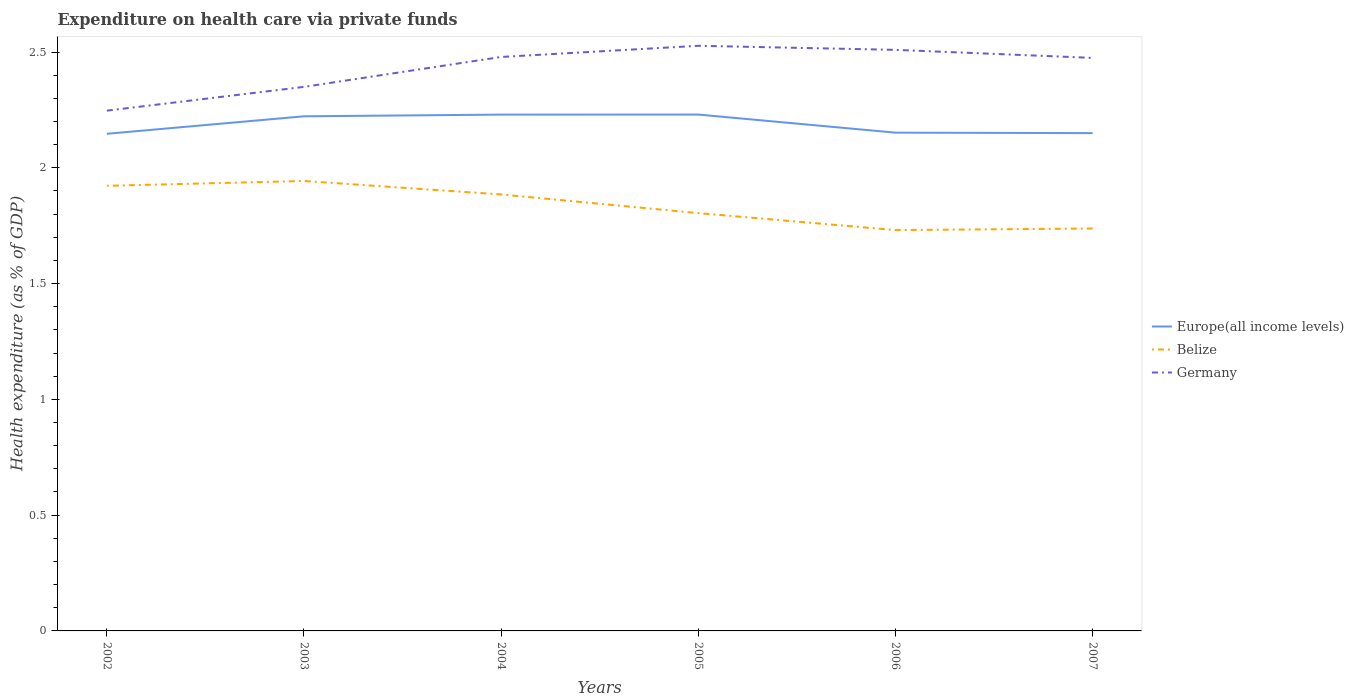How many different coloured lines are there?
Make the answer very short. 3. Across all years, what is the maximum expenditure made on health care in Germany?
Your response must be concise. 2.25. What is the total expenditure made on health care in Germany in the graph?
Offer a very short reply. 0.02. What is the difference between the highest and the second highest expenditure made on health care in Belize?
Provide a short and direct response. 0.21. What is the difference between the highest and the lowest expenditure made on health care in Europe(all income levels)?
Offer a very short reply. 3. How many lines are there?
Provide a short and direct response. 3. How many years are there in the graph?
Offer a terse response. 6. What is the difference between two consecutive major ticks on the Y-axis?
Provide a short and direct response. 0.5. Does the graph contain any zero values?
Make the answer very short. No. What is the title of the graph?
Ensure brevity in your answer.  Expenditure on health care via private funds. Does "Ukraine" appear as one of the legend labels in the graph?
Provide a short and direct response. No. What is the label or title of the X-axis?
Offer a terse response. Years. What is the label or title of the Y-axis?
Give a very brief answer. Health expenditure (as % of GDP). What is the Health expenditure (as % of GDP) of Europe(all income levels) in 2002?
Offer a very short reply. 2.15. What is the Health expenditure (as % of GDP) of Belize in 2002?
Your answer should be compact. 1.92. What is the Health expenditure (as % of GDP) of Germany in 2002?
Your answer should be compact. 2.25. What is the Health expenditure (as % of GDP) of Europe(all income levels) in 2003?
Offer a very short reply. 2.22. What is the Health expenditure (as % of GDP) of Belize in 2003?
Ensure brevity in your answer.  1.94. What is the Health expenditure (as % of GDP) of Germany in 2003?
Your answer should be very brief. 2.35. What is the Health expenditure (as % of GDP) in Europe(all income levels) in 2004?
Your answer should be compact. 2.23. What is the Health expenditure (as % of GDP) of Belize in 2004?
Your answer should be compact. 1.88. What is the Health expenditure (as % of GDP) of Germany in 2004?
Your answer should be compact. 2.48. What is the Health expenditure (as % of GDP) in Europe(all income levels) in 2005?
Provide a short and direct response. 2.23. What is the Health expenditure (as % of GDP) of Belize in 2005?
Your response must be concise. 1.8. What is the Health expenditure (as % of GDP) of Germany in 2005?
Keep it short and to the point. 2.53. What is the Health expenditure (as % of GDP) of Europe(all income levels) in 2006?
Your answer should be compact. 2.15. What is the Health expenditure (as % of GDP) in Belize in 2006?
Offer a terse response. 1.73. What is the Health expenditure (as % of GDP) of Germany in 2006?
Give a very brief answer. 2.51. What is the Health expenditure (as % of GDP) in Europe(all income levels) in 2007?
Your answer should be compact. 2.15. What is the Health expenditure (as % of GDP) in Belize in 2007?
Provide a succinct answer. 1.74. What is the Health expenditure (as % of GDP) in Germany in 2007?
Provide a succinct answer. 2.47. Across all years, what is the maximum Health expenditure (as % of GDP) of Europe(all income levels)?
Offer a very short reply. 2.23. Across all years, what is the maximum Health expenditure (as % of GDP) of Belize?
Your answer should be compact. 1.94. Across all years, what is the maximum Health expenditure (as % of GDP) of Germany?
Offer a terse response. 2.53. Across all years, what is the minimum Health expenditure (as % of GDP) of Europe(all income levels)?
Provide a short and direct response. 2.15. Across all years, what is the minimum Health expenditure (as % of GDP) of Belize?
Your answer should be very brief. 1.73. Across all years, what is the minimum Health expenditure (as % of GDP) in Germany?
Your answer should be compact. 2.25. What is the total Health expenditure (as % of GDP) in Europe(all income levels) in the graph?
Provide a succinct answer. 13.13. What is the total Health expenditure (as % of GDP) of Belize in the graph?
Your answer should be very brief. 11.02. What is the total Health expenditure (as % of GDP) of Germany in the graph?
Make the answer very short. 14.59. What is the difference between the Health expenditure (as % of GDP) of Europe(all income levels) in 2002 and that in 2003?
Provide a short and direct response. -0.08. What is the difference between the Health expenditure (as % of GDP) of Belize in 2002 and that in 2003?
Ensure brevity in your answer.  -0.02. What is the difference between the Health expenditure (as % of GDP) in Germany in 2002 and that in 2003?
Ensure brevity in your answer.  -0.1. What is the difference between the Health expenditure (as % of GDP) of Europe(all income levels) in 2002 and that in 2004?
Your answer should be very brief. -0.08. What is the difference between the Health expenditure (as % of GDP) of Belize in 2002 and that in 2004?
Offer a very short reply. 0.04. What is the difference between the Health expenditure (as % of GDP) in Germany in 2002 and that in 2004?
Offer a terse response. -0.23. What is the difference between the Health expenditure (as % of GDP) in Europe(all income levels) in 2002 and that in 2005?
Make the answer very short. -0.08. What is the difference between the Health expenditure (as % of GDP) in Belize in 2002 and that in 2005?
Your answer should be compact. 0.12. What is the difference between the Health expenditure (as % of GDP) in Germany in 2002 and that in 2005?
Offer a terse response. -0.28. What is the difference between the Health expenditure (as % of GDP) of Europe(all income levels) in 2002 and that in 2006?
Your answer should be very brief. -0. What is the difference between the Health expenditure (as % of GDP) of Belize in 2002 and that in 2006?
Make the answer very short. 0.19. What is the difference between the Health expenditure (as % of GDP) in Germany in 2002 and that in 2006?
Give a very brief answer. -0.26. What is the difference between the Health expenditure (as % of GDP) of Europe(all income levels) in 2002 and that in 2007?
Ensure brevity in your answer.  -0. What is the difference between the Health expenditure (as % of GDP) in Belize in 2002 and that in 2007?
Your answer should be compact. 0.18. What is the difference between the Health expenditure (as % of GDP) of Germany in 2002 and that in 2007?
Provide a succinct answer. -0.23. What is the difference between the Health expenditure (as % of GDP) of Europe(all income levels) in 2003 and that in 2004?
Provide a succinct answer. -0.01. What is the difference between the Health expenditure (as % of GDP) of Belize in 2003 and that in 2004?
Make the answer very short. 0.06. What is the difference between the Health expenditure (as % of GDP) of Germany in 2003 and that in 2004?
Offer a very short reply. -0.13. What is the difference between the Health expenditure (as % of GDP) of Europe(all income levels) in 2003 and that in 2005?
Give a very brief answer. -0.01. What is the difference between the Health expenditure (as % of GDP) of Belize in 2003 and that in 2005?
Your answer should be compact. 0.14. What is the difference between the Health expenditure (as % of GDP) in Germany in 2003 and that in 2005?
Make the answer very short. -0.18. What is the difference between the Health expenditure (as % of GDP) of Europe(all income levels) in 2003 and that in 2006?
Offer a very short reply. 0.07. What is the difference between the Health expenditure (as % of GDP) of Belize in 2003 and that in 2006?
Your answer should be compact. 0.21. What is the difference between the Health expenditure (as % of GDP) of Germany in 2003 and that in 2006?
Offer a terse response. -0.16. What is the difference between the Health expenditure (as % of GDP) of Europe(all income levels) in 2003 and that in 2007?
Provide a succinct answer. 0.07. What is the difference between the Health expenditure (as % of GDP) in Belize in 2003 and that in 2007?
Offer a terse response. 0.21. What is the difference between the Health expenditure (as % of GDP) of Germany in 2003 and that in 2007?
Keep it short and to the point. -0.13. What is the difference between the Health expenditure (as % of GDP) of Europe(all income levels) in 2004 and that in 2005?
Your answer should be compact. -0. What is the difference between the Health expenditure (as % of GDP) in Belize in 2004 and that in 2005?
Your answer should be compact. 0.08. What is the difference between the Health expenditure (as % of GDP) in Germany in 2004 and that in 2005?
Your answer should be compact. -0.05. What is the difference between the Health expenditure (as % of GDP) of Europe(all income levels) in 2004 and that in 2006?
Your answer should be very brief. 0.08. What is the difference between the Health expenditure (as % of GDP) in Belize in 2004 and that in 2006?
Your response must be concise. 0.15. What is the difference between the Health expenditure (as % of GDP) in Germany in 2004 and that in 2006?
Make the answer very short. -0.03. What is the difference between the Health expenditure (as % of GDP) in Europe(all income levels) in 2004 and that in 2007?
Your answer should be compact. 0.08. What is the difference between the Health expenditure (as % of GDP) in Belize in 2004 and that in 2007?
Your answer should be compact. 0.15. What is the difference between the Health expenditure (as % of GDP) in Germany in 2004 and that in 2007?
Your answer should be compact. 0. What is the difference between the Health expenditure (as % of GDP) of Europe(all income levels) in 2005 and that in 2006?
Give a very brief answer. 0.08. What is the difference between the Health expenditure (as % of GDP) in Belize in 2005 and that in 2006?
Offer a very short reply. 0.07. What is the difference between the Health expenditure (as % of GDP) of Germany in 2005 and that in 2006?
Ensure brevity in your answer.  0.02. What is the difference between the Health expenditure (as % of GDP) of Europe(all income levels) in 2005 and that in 2007?
Provide a succinct answer. 0.08. What is the difference between the Health expenditure (as % of GDP) in Belize in 2005 and that in 2007?
Provide a short and direct response. 0.07. What is the difference between the Health expenditure (as % of GDP) of Germany in 2005 and that in 2007?
Your response must be concise. 0.05. What is the difference between the Health expenditure (as % of GDP) of Europe(all income levels) in 2006 and that in 2007?
Your answer should be very brief. 0. What is the difference between the Health expenditure (as % of GDP) of Belize in 2006 and that in 2007?
Offer a terse response. -0.01. What is the difference between the Health expenditure (as % of GDP) of Germany in 2006 and that in 2007?
Make the answer very short. 0.03. What is the difference between the Health expenditure (as % of GDP) in Europe(all income levels) in 2002 and the Health expenditure (as % of GDP) in Belize in 2003?
Make the answer very short. 0.2. What is the difference between the Health expenditure (as % of GDP) of Europe(all income levels) in 2002 and the Health expenditure (as % of GDP) of Germany in 2003?
Give a very brief answer. -0.2. What is the difference between the Health expenditure (as % of GDP) in Belize in 2002 and the Health expenditure (as % of GDP) in Germany in 2003?
Provide a short and direct response. -0.43. What is the difference between the Health expenditure (as % of GDP) of Europe(all income levels) in 2002 and the Health expenditure (as % of GDP) of Belize in 2004?
Make the answer very short. 0.26. What is the difference between the Health expenditure (as % of GDP) in Europe(all income levels) in 2002 and the Health expenditure (as % of GDP) in Germany in 2004?
Your answer should be very brief. -0.33. What is the difference between the Health expenditure (as % of GDP) of Belize in 2002 and the Health expenditure (as % of GDP) of Germany in 2004?
Your response must be concise. -0.56. What is the difference between the Health expenditure (as % of GDP) of Europe(all income levels) in 2002 and the Health expenditure (as % of GDP) of Belize in 2005?
Offer a terse response. 0.34. What is the difference between the Health expenditure (as % of GDP) of Europe(all income levels) in 2002 and the Health expenditure (as % of GDP) of Germany in 2005?
Provide a succinct answer. -0.38. What is the difference between the Health expenditure (as % of GDP) of Belize in 2002 and the Health expenditure (as % of GDP) of Germany in 2005?
Provide a succinct answer. -0.6. What is the difference between the Health expenditure (as % of GDP) of Europe(all income levels) in 2002 and the Health expenditure (as % of GDP) of Belize in 2006?
Your answer should be compact. 0.42. What is the difference between the Health expenditure (as % of GDP) of Europe(all income levels) in 2002 and the Health expenditure (as % of GDP) of Germany in 2006?
Your answer should be compact. -0.36. What is the difference between the Health expenditure (as % of GDP) in Belize in 2002 and the Health expenditure (as % of GDP) in Germany in 2006?
Keep it short and to the point. -0.59. What is the difference between the Health expenditure (as % of GDP) of Europe(all income levels) in 2002 and the Health expenditure (as % of GDP) of Belize in 2007?
Give a very brief answer. 0.41. What is the difference between the Health expenditure (as % of GDP) in Europe(all income levels) in 2002 and the Health expenditure (as % of GDP) in Germany in 2007?
Provide a succinct answer. -0.33. What is the difference between the Health expenditure (as % of GDP) of Belize in 2002 and the Health expenditure (as % of GDP) of Germany in 2007?
Your response must be concise. -0.55. What is the difference between the Health expenditure (as % of GDP) of Europe(all income levels) in 2003 and the Health expenditure (as % of GDP) of Belize in 2004?
Offer a terse response. 0.34. What is the difference between the Health expenditure (as % of GDP) in Europe(all income levels) in 2003 and the Health expenditure (as % of GDP) in Germany in 2004?
Offer a very short reply. -0.26. What is the difference between the Health expenditure (as % of GDP) of Belize in 2003 and the Health expenditure (as % of GDP) of Germany in 2004?
Ensure brevity in your answer.  -0.54. What is the difference between the Health expenditure (as % of GDP) of Europe(all income levels) in 2003 and the Health expenditure (as % of GDP) of Belize in 2005?
Provide a succinct answer. 0.42. What is the difference between the Health expenditure (as % of GDP) in Europe(all income levels) in 2003 and the Health expenditure (as % of GDP) in Germany in 2005?
Your answer should be compact. -0.3. What is the difference between the Health expenditure (as % of GDP) in Belize in 2003 and the Health expenditure (as % of GDP) in Germany in 2005?
Offer a terse response. -0.58. What is the difference between the Health expenditure (as % of GDP) in Europe(all income levels) in 2003 and the Health expenditure (as % of GDP) in Belize in 2006?
Make the answer very short. 0.49. What is the difference between the Health expenditure (as % of GDP) of Europe(all income levels) in 2003 and the Health expenditure (as % of GDP) of Germany in 2006?
Provide a succinct answer. -0.29. What is the difference between the Health expenditure (as % of GDP) of Belize in 2003 and the Health expenditure (as % of GDP) of Germany in 2006?
Your response must be concise. -0.57. What is the difference between the Health expenditure (as % of GDP) of Europe(all income levels) in 2003 and the Health expenditure (as % of GDP) of Belize in 2007?
Give a very brief answer. 0.48. What is the difference between the Health expenditure (as % of GDP) in Europe(all income levels) in 2003 and the Health expenditure (as % of GDP) in Germany in 2007?
Ensure brevity in your answer.  -0.25. What is the difference between the Health expenditure (as % of GDP) in Belize in 2003 and the Health expenditure (as % of GDP) in Germany in 2007?
Your response must be concise. -0.53. What is the difference between the Health expenditure (as % of GDP) of Europe(all income levels) in 2004 and the Health expenditure (as % of GDP) of Belize in 2005?
Offer a very short reply. 0.43. What is the difference between the Health expenditure (as % of GDP) of Europe(all income levels) in 2004 and the Health expenditure (as % of GDP) of Germany in 2005?
Keep it short and to the point. -0.3. What is the difference between the Health expenditure (as % of GDP) of Belize in 2004 and the Health expenditure (as % of GDP) of Germany in 2005?
Make the answer very short. -0.64. What is the difference between the Health expenditure (as % of GDP) in Europe(all income levels) in 2004 and the Health expenditure (as % of GDP) in Belize in 2006?
Make the answer very short. 0.5. What is the difference between the Health expenditure (as % of GDP) in Europe(all income levels) in 2004 and the Health expenditure (as % of GDP) in Germany in 2006?
Your answer should be very brief. -0.28. What is the difference between the Health expenditure (as % of GDP) of Belize in 2004 and the Health expenditure (as % of GDP) of Germany in 2006?
Provide a short and direct response. -0.62. What is the difference between the Health expenditure (as % of GDP) of Europe(all income levels) in 2004 and the Health expenditure (as % of GDP) of Belize in 2007?
Your response must be concise. 0.49. What is the difference between the Health expenditure (as % of GDP) of Europe(all income levels) in 2004 and the Health expenditure (as % of GDP) of Germany in 2007?
Your answer should be compact. -0.24. What is the difference between the Health expenditure (as % of GDP) of Belize in 2004 and the Health expenditure (as % of GDP) of Germany in 2007?
Offer a very short reply. -0.59. What is the difference between the Health expenditure (as % of GDP) in Europe(all income levels) in 2005 and the Health expenditure (as % of GDP) in Belize in 2006?
Your answer should be very brief. 0.5. What is the difference between the Health expenditure (as % of GDP) of Europe(all income levels) in 2005 and the Health expenditure (as % of GDP) of Germany in 2006?
Make the answer very short. -0.28. What is the difference between the Health expenditure (as % of GDP) in Belize in 2005 and the Health expenditure (as % of GDP) in Germany in 2006?
Give a very brief answer. -0.7. What is the difference between the Health expenditure (as % of GDP) of Europe(all income levels) in 2005 and the Health expenditure (as % of GDP) of Belize in 2007?
Make the answer very short. 0.49. What is the difference between the Health expenditure (as % of GDP) in Europe(all income levels) in 2005 and the Health expenditure (as % of GDP) in Germany in 2007?
Ensure brevity in your answer.  -0.24. What is the difference between the Health expenditure (as % of GDP) in Belize in 2005 and the Health expenditure (as % of GDP) in Germany in 2007?
Offer a terse response. -0.67. What is the difference between the Health expenditure (as % of GDP) in Europe(all income levels) in 2006 and the Health expenditure (as % of GDP) in Belize in 2007?
Offer a terse response. 0.41. What is the difference between the Health expenditure (as % of GDP) of Europe(all income levels) in 2006 and the Health expenditure (as % of GDP) of Germany in 2007?
Your answer should be very brief. -0.32. What is the difference between the Health expenditure (as % of GDP) of Belize in 2006 and the Health expenditure (as % of GDP) of Germany in 2007?
Offer a terse response. -0.74. What is the average Health expenditure (as % of GDP) of Europe(all income levels) per year?
Provide a short and direct response. 2.19. What is the average Health expenditure (as % of GDP) in Belize per year?
Provide a short and direct response. 1.84. What is the average Health expenditure (as % of GDP) in Germany per year?
Give a very brief answer. 2.43. In the year 2002, what is the difference between the Health expenditure (as % of GDP) in Europe(all income levels) and Health expenditure (as % of GDP) in Belize?
Keep it short and to the point. 0.22. In the year 2002, what is the difference between the Health expenditure (as % of GDP) in Europe(all income levels) and Health expenditure (as % of GDP) in Germany?
Your answer should be compact. -0.1. In the year 2002, what is the difference between the Health expenditure (as % of GDP) of Belize and Health expenditure (as % of GDP) of Germany?
Provide a succinct answer. -0.32. In the year 2003, what is the difference between the Health expenditure (as % of GDP) in Europe(all income levels) and Health expenditure (as % of GDP) in Belize?
Make the answer very short. 0.28. In the year 2003, what is the difference between the Health expenditure (as % of GDP) in Europe(all income levels) and Health expenditure (as % of GDP) in Germany?
Make the answer very short. -0.13. In the year 2003, what is the difference between the Health expenditure (as % of GDP) in Belize and Health expenditure (as % of GDP) in Germany?
Your answer should be compact. -0.41. In the year 2004, what is the difference between the Health expenditure (as % of GDP) in Europe(all income levels) and Health expenditure (as % of GDP) in Belize?
Give a very brief answer. 0.34. In the year 2004, what is the difference between the Health expenditure (as % of GDP) of Europe(all income levels) and Health expenditure (as % of GDP) of Germany?
Offer a terse response. -0.25. In the year 2004, what is the difference between the Health expenditure (as % of GDP) of Belize and Health expenditure (as % of GDP) of Germany?
Ensure brevity in your answer.  -0.59. In the year 2005, what is the difference between the Health expenditure (as % of GDP) of Europe(all income levels) and Health expenditure (as % of GDP) of Belize?
Your answer should be very brief. 0.43. In the year 2005, what is the difference between the Health expenditure (as % of GDP) of Europe(all income levels) and Health expenditure (as % of GDP) of Germany?
Your answer should be very brief. -0.3. In the year 2005, what is the difference between the Health expenditure (as % of GDP) in Belize and Health expenditure (as % of GDP) in Germany?
Offer a terse response. -0.72. In the year 2006, what is the difference between the Health expenditure (as % of GDP) of Europe(all income levels) and Health expenditure (as % of GDP) of Belize?
Keep it short and to the point. 0.42. In the year 2006, what is the difference between the Health expenditure (as % of GDP) of Europe(all income levels) and Health expenditure (as % of GDP) of Germany?
Provide a short and direct response. -0.36. In the year 2006, what is the difference between the Health expenditure (as % of GDP) in Belize and Health expenditure (as % of GDP) in Germany?
Give a very brief answer. -0.78. In the year 2007, what is the difference between the Health expenditure (as % of GDP) of Europe(all income levels) and Health expenditure (as % of GDP) of Belize?
Offer a terse response. 0.41. In the year 2007, what is the difference between the Health expenditure (as % of GDP) in Europe(all income levels) and Health expenditure (as % of GDP) in Germany?
Ensure brevity in your answer.  -0.32. In the year 2007, what is the difference between the Health expenditure (as % of GDP) in Belize and Health expenditure (as % of GDP) in Germany?
Your response must be concise. -0.74. What is the ratio of the Health expenditure (as % of GDP) in Belize in 2002 to that in 2003?
Keep it short and to the point. 0.99. What is the ratio of the Health expenditure (as % of GDP) of Germany in 2002 to that in 2003?
Provide a short and direct response. 0.96. What is the ratio of the Health expenditure (as % of GDP) in Europe(all income levels) in 2002 to that in 2004?
Your answer should be very brief. 0.96. What is the ratio of the Health expenditure (as % of GDP) of Belize in 2002 to that in 2004?
Offer a very short reply. 1.02. What is the ratio of the Health expenditure (as % of GDP) of Germany in 2002 to that in 2004?
Give a very brief answer. 0.91. What is the ratio of the Health expenditure (as % of GDP) in Europe(all income levels) in 2002 to that in 2005?
Ensure brevity in your answer.  0.96. What is the ratio of the Health expenditure (as % of GDP) in Belize in 2002 to that in 2005?
Your response must be concise. 1.07. What is the ratio of the Health expenditure (as % of GDP) in Germany in 2002 to that in 2005?
Offer a very short reply. 0.89. What is the ratio of the Health expenditure (as % of GDP) in Europe(all income levels) in 2002 to that in 2006?
Offer a terse response. 1. What is the ratio of the Health expenditure (as % of GDP) in Belize in 2002 to that in 2006?
Ensure brevity in your answer.  1.11. What is the ratio of the Health expenditure (as % of GDP) of Germany in 2002 to that in 2006?
Offer a very short reply. 0.9. What is the ratio of the Health expenditure (as % of GDP) of Europe(all income levels) in 2002 to that in 2007?
Give a very brief answer. 1. What is the ratio of the Health expenditure (as % of GDP) of Belize in 2002 to that in 2007?
Offer a very short reply. 1.11. What is the ratio of the Health expenditure (as % of GDP) of Germany in 2002 to that in 2007?
Keep it short and to the point. 0.91. What is the ratio of the Health expenditure (as % of GDP) of Belize in 2003 to that in 2004?
Offer a terse response. 1.03. What is the ratio of the Health expenditure (as % of GDP) of Germany in 2003 to that in 2004?
Offer a very short reply. 0.95. What is the ratio of the Health expenditure (as % of GDP) of Belize in 2003 to that in 2005?
Give a very brief answer. 1.08. What is the ratio of the Health expenditure (as % of GDP) in Germany in 2003 to that in 2005?
Make the answer very short. 0.93. What is the ratio of the Health expenditure (as % of GDP) in Europe(all income levels) in 2003 to that in 2006?
Offer a very short reply. 1.03. What is the ratio of the Health expenditure (as % of GDP) in Belize in 2003 to that in 2006?
Offer a very short reply. 1.12. What is the ratio of the Health expenditure (as % of GDP) in Germany in 2003 to that in 2006?
Your answer should be compact. 0.94. What is the ratio of the Health expenditure (as % of GDP) of Europe(all income levels) in 2003 to that in 2007?
Ensure brevity in your answer.  1.03. What is the ratio of the Health expenditure (as % of GDP) in Belize in 2003 to that in 2007?
Your answer should be very brief. 1.12. What is the ratio of the Health expenditure (as % of GDP) of Germany in 2003 to that in 2007?
Keep it short and to the point. 0.95. What is the ratio of the Health expenditure (as % of GDP) in Europe(all income levels) in 2004 to that in 2005?
Provide a short and direct response. 1. What is the ratio of the Health expenditure (as % of GDP) in Belize in 2004 to that in 2005?
Your response must be concise. 1.04. What is the ratio of the Health expenditure (as % of GDP) of Germany in 2004 to that in 2005?
Provide a succinct answer. 0.98. What is the ratio of the Health expenditure (as % of GDP) of Europe(all income levels) in 2004 to that in 2006?
Provide a succinct answer. 1.04. What is the ratio of the Health expenditure (as % of GDP) of Belize in 2004 to that in 2006?
Offer a terse response. 1.09. What is the ratio of the Health expenditure (as % of GDP) in Europe(all income levels) in 2004 to that in 2007?
Make the answer very short. 1.04. What is the ratio of the Health expenditure (as % of GDP) in Belize in 2004 to that in 2007?
Your response must be concise. 1.08. What is the ratio of the Health expenditure (as % of GDP) of Germany in 2004 to that in 2007?
Make the answer very short. 1. What is the ratio of the Health expenditure (as % of GDP) in Europe(all income levels) in 2005 to that in 2006?
Your answer should be very brief. 1.04. What is the ratio of the Health expenditure (as % of GDP) of Belize in 2005 to that in 2006?
Provide a succinct answer. 1.04. What is the ratio of the Health expenditure (as % of GDP) in Europe(all income levels) in 2005 to that in 2007?
Make the answer very short. 1.04. What is the ratio of the Health expenditure (as % of GDP) in Belize in 2005 to that in 2007?
Your answer should be very brief. 1.04. What is the ratio of the Health expenditure (as % of GDP) of Germany in 2005 to that in 2007?
Provide a short and direct response. 1.02. What is the ratio of the Health expenditure (as % of GDP) in Europe(all income levels) in 2006 to that in 2007?
Your response must be concise. 1. What is the difference between the highest and the second highest Health expenditure (as % of GDP) in Europe(all income levels)?
Make the answer very short. 0. What is the difference between the highest and the second highest Health expenditure (as % of GDP) of Belize?
Your response must be concise. 0.02. What is the difference between the highest and the second highest Health expenditure (as % of GDP) of Germany?
Your response must be concise. 0.02. What is the difference between the highest and the lowest Health expenditure (as % of GDP) in Europe(all income levels)?
Give a very brief answer. 0.08. What is the difference between the highest and the lowest Health expenditure (as % of GDP) in Belize?
Give a very brief answer. 0.21. What is the difference between the highest and the lowest Health expenditure (as % of GDP) in Germany?
Your answer should be compact. 0.28. 